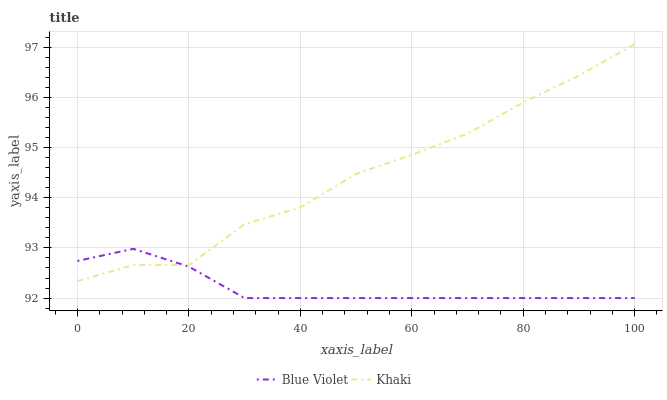Does Blue Violet have the minimum area under the curve?
Answer yes or no. Yes. Does Khaki have the maximum area under the curve?
Answer yes or no. Yes. Does Blue Violet have the maximum area under the curve?
Answer yes or no. No. Is Blue Violet the smoothest?
Answer yes or no. Yes. Is Khaki the roughest?
Answer yes or no. Yes. Is Blue Violet the roughest?
Answer yes or no. No. Does Blue Violet have the lowest value?
Answer yes or no. Yes. Does Khaki have the highest value?
Answer yes or no. Yes. Does Blue Violet have the highest value?
Answer yes or no. No. Does Khaki intersect Blue Violet?
Answer yes or no. Yes. Is Khaki less than Blue Violet?
Answer yes or no. No. Is Khaki greater than Blue Violet?
Answer yes or no. No. 